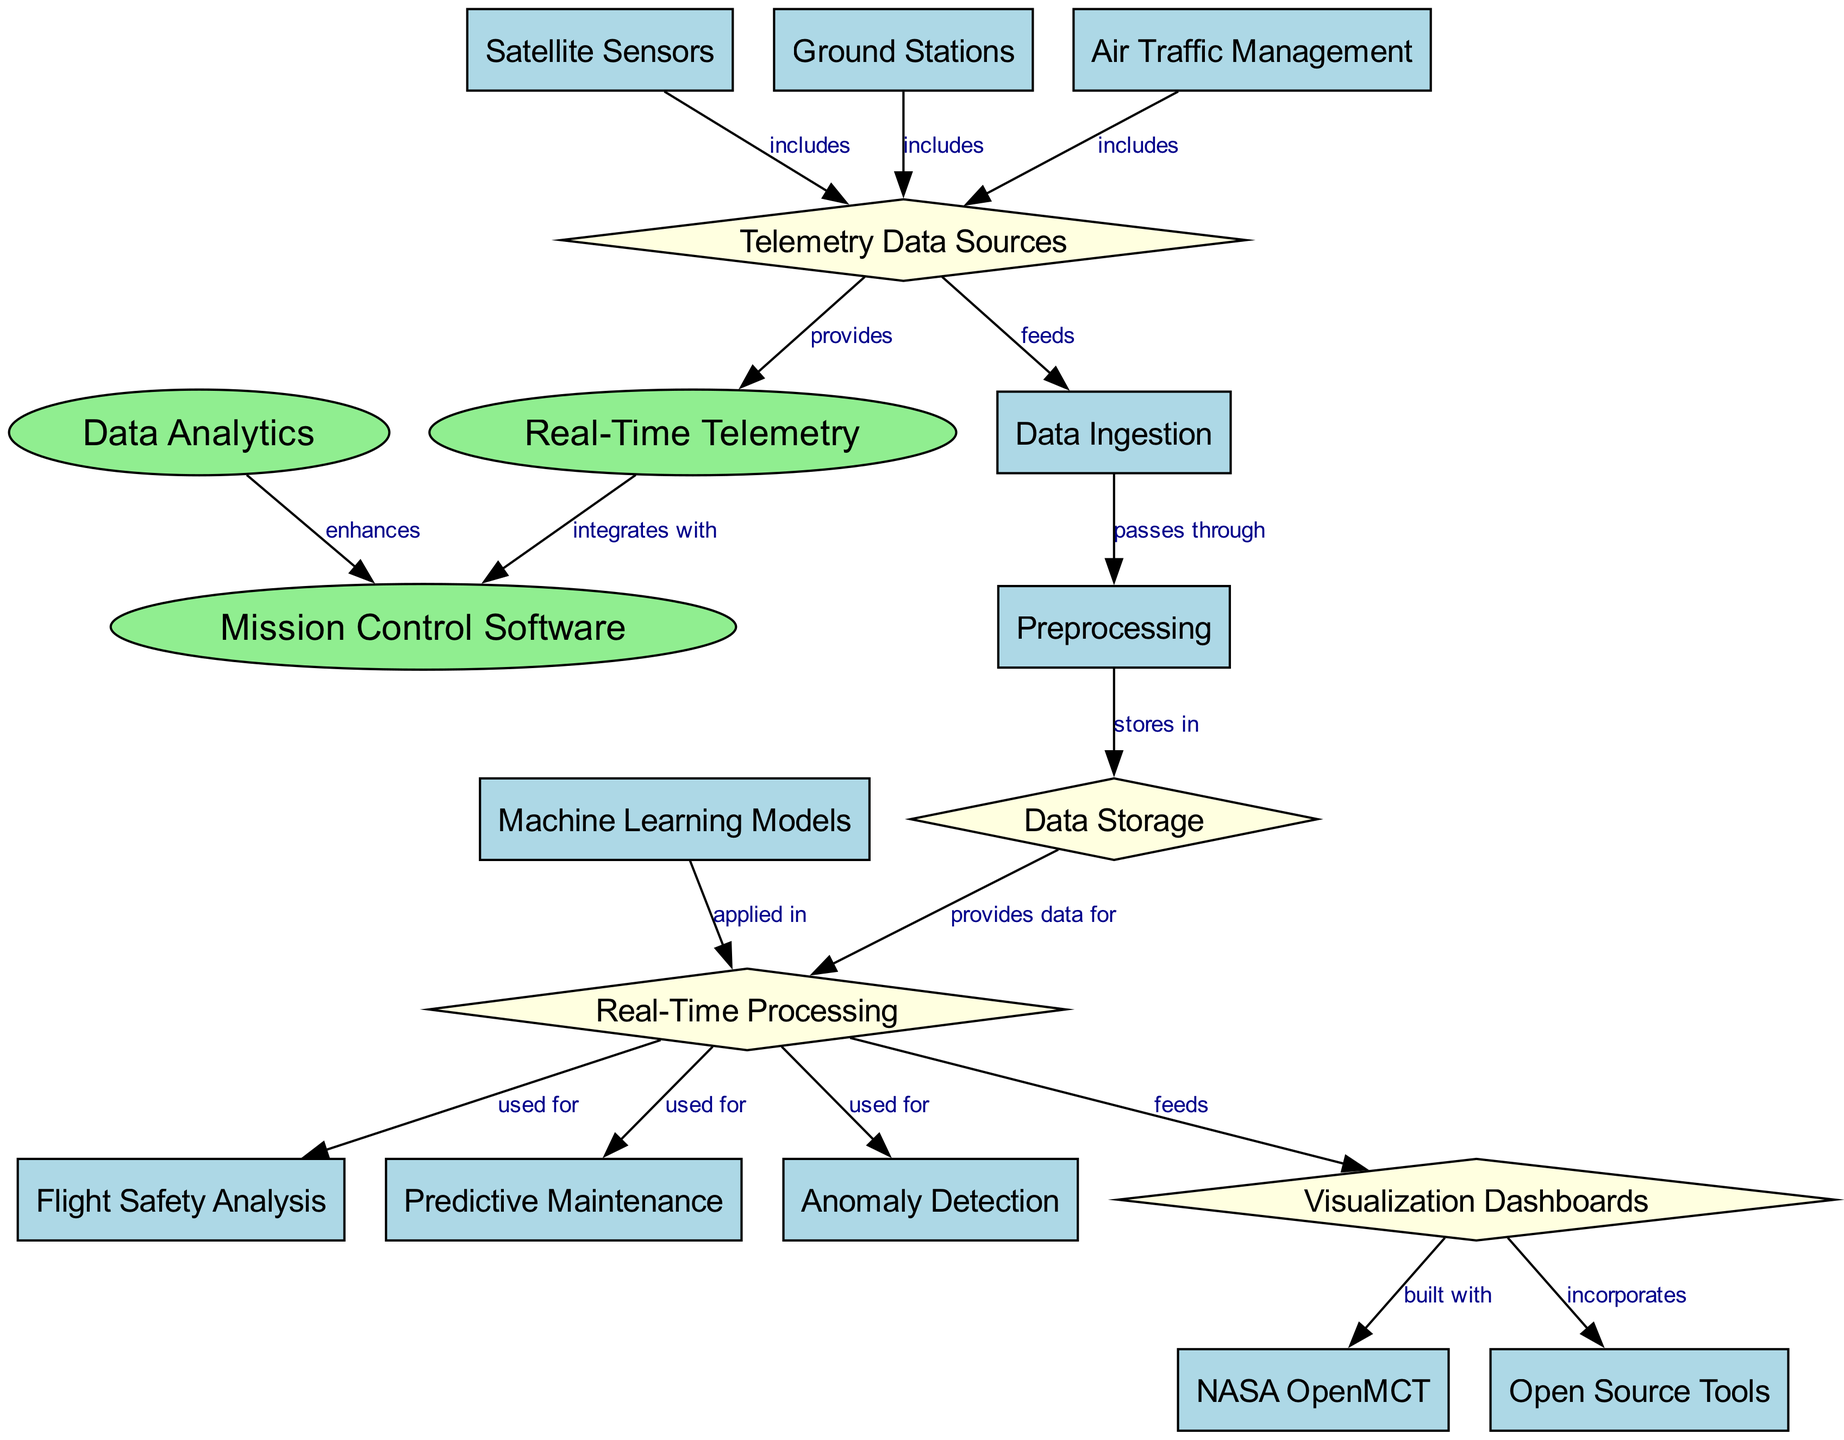What is the main component that integrates with Real-Time Telemetry? According to the diagram, the main component that integrates with Real-Time Telemetry is the Mission Control Software, as indicated by the directed edge labeled "integrates with" from node 1 to node 3.
Answer: Mission Control Software How many data sources are listed as providing telemetry data? The diagram indicates three data sources that provide telemetry data, which are Satellite Sensors, Ground Stations, and Air Traffic Management, connected to the Telemetry Data Sources node.
Answer: Three What type of processing is applied to Real-Time Data Transmission? Real-Time Processing is the type of processing indicated in the diagram that is applied to the Real-Time Data Transmission, as shown in the connection from Data Storage to Real-Time Processing.
Answer: Real-Time Processing What is used for Flight Safety Analysis? The diagram shows that Real-Time Processing is used for Flight Safety Analysis, as evidenced by the direct connection from Real-Time Processing to Flight Safety Analysis.
Answer: Real-Time Processing Which tool is incorporated into Visualization Dashboards? The diagram states that NASA OpenMCT is built into Visualization Dashboards, as illustrated by the directed edge connecting Visualization Dashboards to NASA OpenMCT.
Answer: NASA OpenMCT What is the first stage in the data flow after Telemetry Data Sources? The first stage in the data flow after Telemetry Data Sources is Data Ingestion, as indicated by the edge labeled "feeds" connecting Telemetry Data Sources to Data Ingestion.
Answer: Data Ingestion How does Data Analytics affect Mission Control Software? Data Analytics enhances Mission Control Software, as the diagram clearly indicates the relationship with an edge labeled "enhances" between Data Analytics and Mission Control Software.
Answer: Enhances Which nodes provide telemetry data? The nodes that provide telemetry data according to the diagram are Satellite Sensors, Ground Stations, and Air Traffic Management, all connected to Telemetry Data Sources.
Answer: Satellite Sensors, Ground Stations, Air Traffic Management What is the end result of applying machine learning models? The end result of applying machine learning models, as depicted in the diagram, is the Real-Time Processing for various applications such as Flight Safety Analysis and Predictive Maintenance.
Answer: Real-Time Processing 